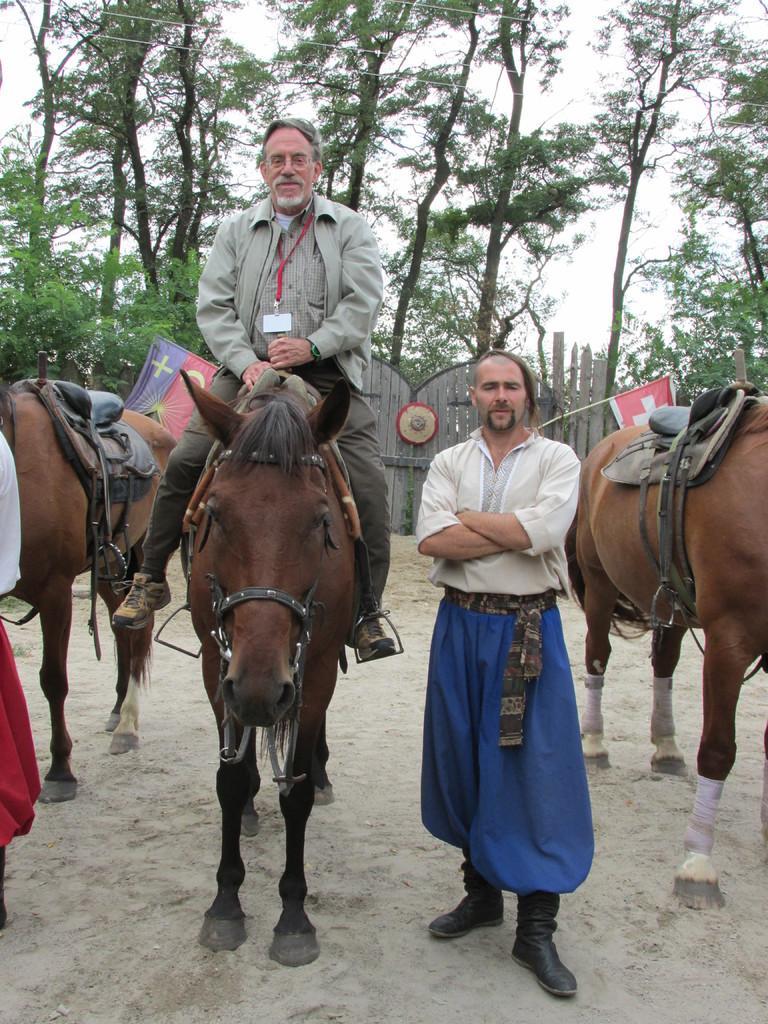Could you give a brief overview of what you see in this image? In this image we can see a person sitting on the animal and beside him we can see a person standing. We can also see trees, animals, flags and sky. 